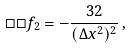<formula> <loc_0><loc_0><loc_500><loc_500>\Box \Box f _ { 2 } = - \frac { 3 2 } { ( \Delta x ^ { 2 } ) ^ { 2 } } \, ,</formula> 